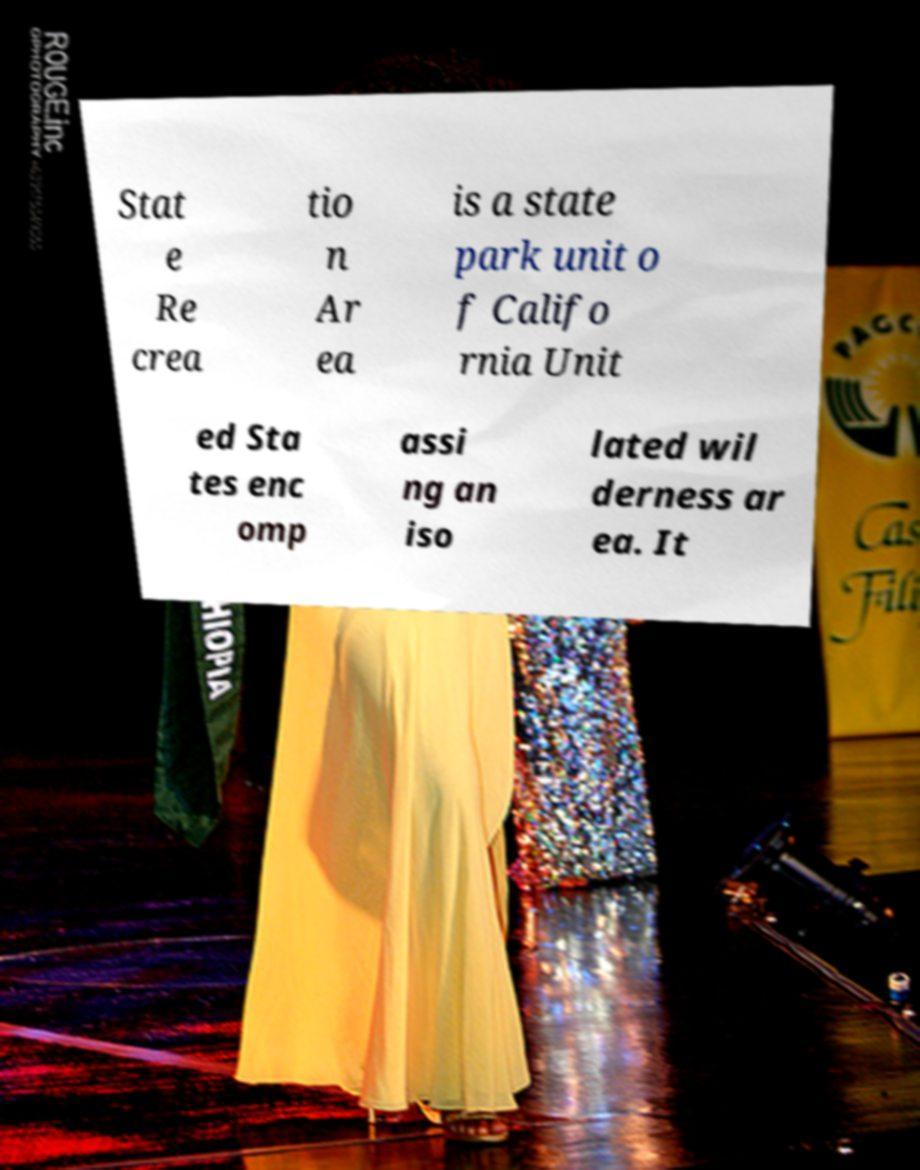I need the written content from this picture converted into text. Can you do that? Stat e Re crea tio n Ar ea is a state park unit o f Califo rnia Unit ed Sta tes enc omp assi ng an iso lated wil derness ar ea. It 